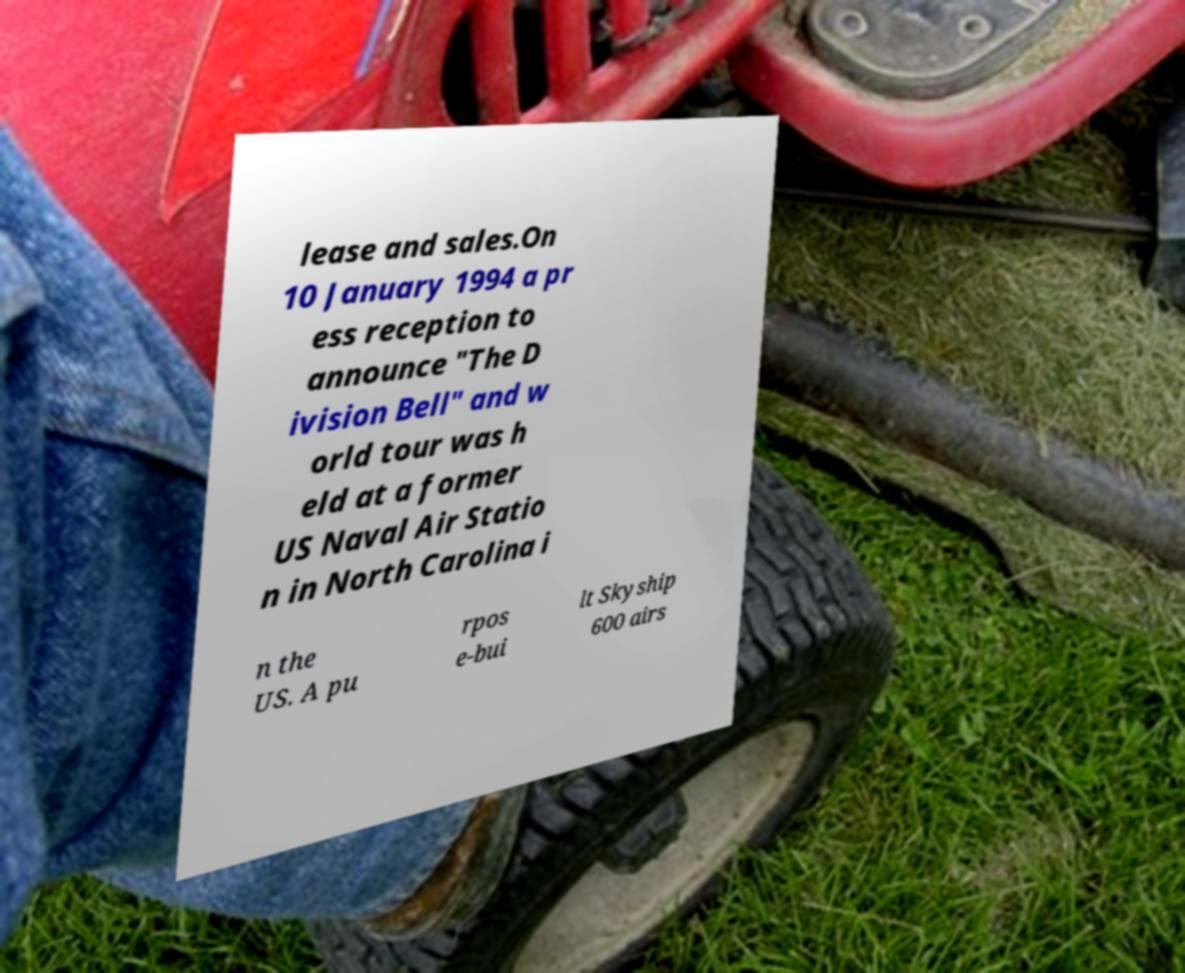Can you read and provide the text displayed in the image?This photo seems to have some interesting text. Can you extract and type it out for me? lease and sales.On 10 January 1994 a pr ess reception to announce "The D ivision Bell" and w orld tour was h eld at a former US Naval Air Statio n in North Carolina i n the US. A pu rpos e-bui lt Skyship 600 airs 